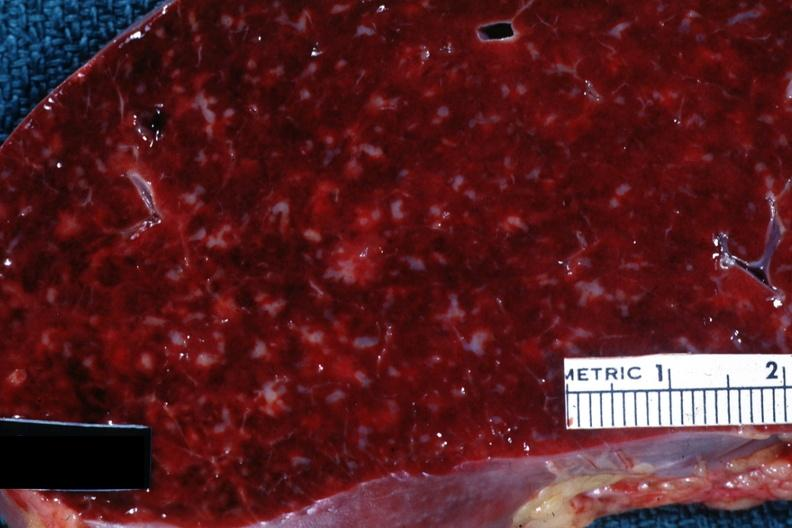what does this image show?
Answer the question using a single word or phrase. Close-up with obvious small infiltrates of something 